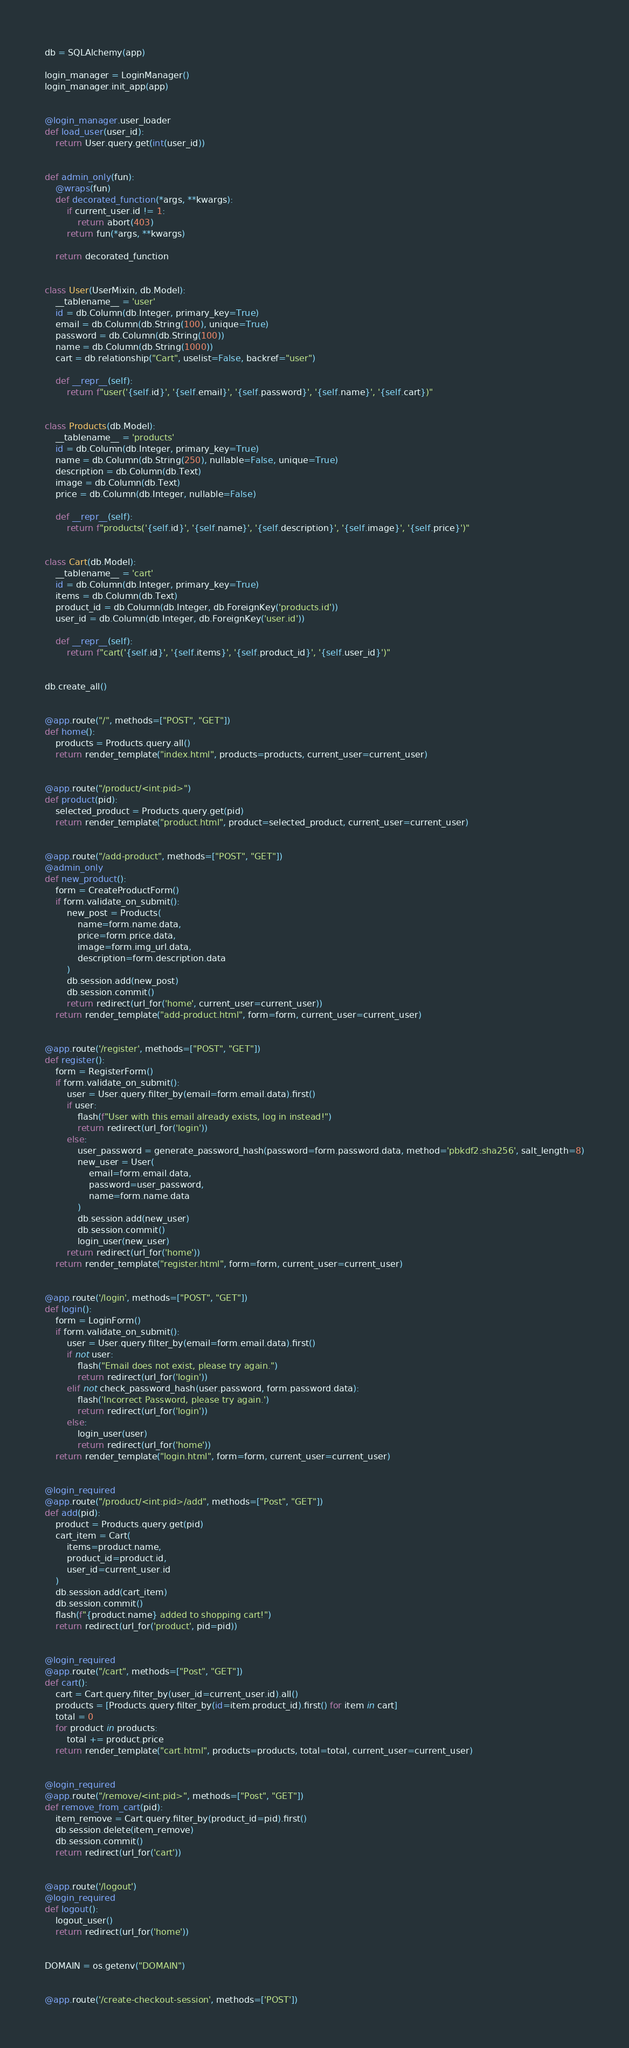<code> <loc_0><loc_0><loc_500><loc_500><_Python_>db = SQLAlchemy(app)

login_manager = LoginManager()
login_manager.init_app(app)


@login_manager.user_loader
def load_user(user_id):
    return User.query.get(int(user_id))


def admin_only(fun):
    @wraps(fun)
    def decorated_function(*args, **kwargs):
        if current_user.id != 1:
            return abort(403)
        return fun(*args, **kwargs)

    return decorated_function


class User(UserMixin, db.Model):
    __tablename__ = 'user'
    id = db.Column(db.Integer, primary_key=True)
    email = db.Column(db.String(100), unique=True)
    password = db.Column(db.String(100))
    name = db.Column(db.String(1000))
    cart = db.relationship("Cart", uselist=False, backref="user")

    def __repr__(self):
        return f"user('{self.id}', '{self.email}', '{self.password}', '{self.name}', '{self.cart})"


class Products(db.Model):
    __tablename__ = 'products'
    id = db.Column(db.Integer, primary_key=True)
    name = db.Column(db.String(250), nullable=False, unique=True)
    description = db.Column(db.Text)
    image = db.Column(db.Text)
    price = db.Column(db.Integer, nullable=False)

    def __repr__(self):
        return f"products('{self.id}', '{self.name}', '{self.description}', '{self.image}', '{self.price}')"


class Cart(db.Model):
    __tablename__ = 'cart'
    id = db.Column(db.Integer, primary_key=True)
    items = db.Column(db.Text)
    product_id = db.Column(db.Integer, db.ForeignKey('products.id'))
    user_id = db.Column(db.Integer, db.ForeignKey('user.id'))

    def __repr__(self):
        return f"cart('{self.id}', '{self.items}', '{self.product_id}', '{self.user_id}')"


db.create_all()


@app.route("/", methods=["POST", "GET"])
def home():
    products = Products.query.all()
    return render_template("index.html", products=products, current_user=current_user)


@app.route("/product/<int:pid>")
def product(pid):
    selected_product = Products.query.get(pid)
    return render_template("product.html", product=selected_product, current_user=current_user)


@app.route("/add-product", methods=["POST", "GET"])
@admin_only
def new_product():
    form = CreateProductForm()
    if form.validate_on_submit():
        new_post = Products(
            name=form.name.data,
            price=form.price.data,
            image=form.img_url.data,
            description=form.description.data
        )
        db.session.add(new_post)
        db.session.commit()
        return redirect(url_for('home', current_user=current_user))
    return render_template("add-product.html", form=form, current_user=current_user)


@app.route('/register', methods=["POST", "GET"])
def register():
    form = RegisterForm()
    if form.validate_on_submit():
        user = User.query.filter_by(email=form.email.data).first()
        if user:
            flash(f"User with this email already exists, log in instead!")
            return redirect(url_for('login'))
        else:
            user_password = generate_password_hash(password=form.password.data, method='pbkdf2:sha256', salt_length=8)
            new_user = User(
                email=form.email.data,
                password=user_password,
                name=form.name.data
            )
            db.session.add(new_user)
            db.session.commit()
            login_user(new_user)
        return redirect(url_for('home'))
    return render_template("register.html", form=form, current_user=current_user)


@app.route('/login', methods=["POST", "GET"])
def login():
    form = LoginForm()
    if form.validate_on_submit():
        user = User.query.filter_by(email=form.email.data).first()
        if not user:
            flash("Email does not exist, please try again.")
            return redirect(url_for('login'))
        elif not check_password_hash(user.password, form.password.data):
            flash('Incorrect Password, please try again.')
            return redirect(url_for('login'))
        else:
            login_user(user)
            return redirect(url_for('home'))
    return render_template("login.html", form=form, current_user=current_user)


@login_required
@app.route("/product/<int:pid>/add", methods=["Post", "GET"])
def add(pid):
    product = Products.query.get(pid)
    cart_item = Cart(
        items=product.name,
        product_id=product.id,
        user_id=current_user.id
    )
    db.session.add(cart_item)
    db.session.commit()
    flash(f"{product.name} added to shopping cart!")
    return redirect(url_for('product', pid=pid))


@login_required
@app.route("/cart", methods=["Post", "GET"])
def cart():
    cart = Cart.query.filter_by(user_id=current_user.id).all()
    products = [Products.query.filter_by(id=item.product_id).first() for item in cart]
    total = 0
    for product in products:
        total += product.price
    return render_template("cart.html", products=products, total=total, current_user=current_user)


@login_required
@app.route("/remove/<int:pid>", methods=["Post", "GET"])
def remove_from_cart(pid):
    item_remove = Cart.query.filter_by(product_id=pid).first()
    db.session.delete(item_remove)
    db.session.commit()
    return redirect(url_for('cart'))


@app.route('/logout')
@login_required
def logout():
    logout_user()
    return redirect(url_for('home'))


DOMAIN = os.getenv("DOMAIN")


@app.route('/create-checkout-session', methods=['POST'])</code> 